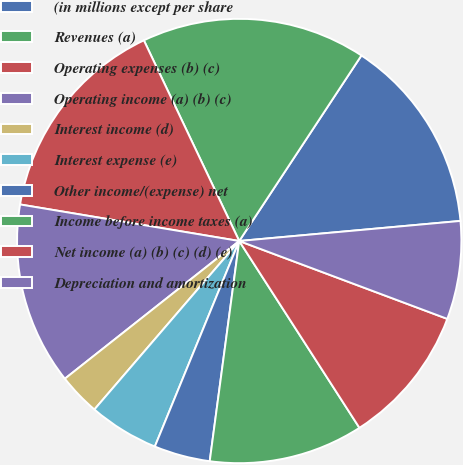Convert chart. <chart><loc_0><loc_0><loc_500><loc_500><pie_chart><fcel>(in millions except per share<fcel>Revenues (a)<fcel>Operating expenses (b) (c)<fcel>Operating income (a) (b) (c)<fcel>Interest income (d)<fcel>Interest expense (e)<fcel>Other income/(expense) net<fcel>Income before income taxes (a)<fcel>Net income (a) (b) (c) (d) (e)<fcel>Depreciation and amortization<nl><fcel>14.29%<fcel>16.33%<fcel>15.31%<fcel>13.27%<fcel>3.06%<fcel>5.1%<fcel>4.08%<fcel>11.22%<fcel>10.2%<fcel>7.14%<nl></chart> 